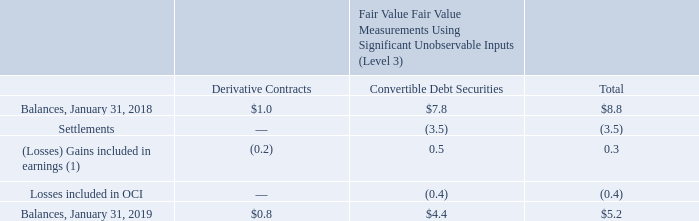Autodesk applies fair value accounting for certain financial assets and liabilities, which consist of cash equivalents, marketable securities, and other financial instruments, on a recurring basis. The Company defines fair value as the price that would be received from selling an asset or paid to transfer a liability in an orderly transaction between market participants at the measurement date. Fair value is estimated by applying the following hierarchy, which prioritizes the inputs used to measure fair value into three levels and bases the categorization within the hierarchy upon the lowest level of input that is available and significant to the fair value measurement: (Level 1) observable inputs such as quoted prices in active markets; (Level 2) inputs other than quoted prices in active markets for identical assets and liabilities, quoted prices for identical or similar assets or liabilities in inactive markets, or other inputs that are observable or can be corroborated by observable market data for substantially the full term of the assets or liabilities; and (Level 3) unobservable inputs for which there is little or no market data, which require Autodesk to develop its own assumptions. When determining fair value, Autodesk uses observable market data and relies on unobservable inputs only when observable market data is not available. Autodesk reviews for any potential changes on a quarterly basis, in conjunction with our fiscal quarter-end close.
Autodesk's cash equivalents, marketable securities, and financial instruments are primarily classified within Level 1 or Level 2 of the fair value hierarchy. Autodesk values its securities on pricing from pricing vendors, who may use quoted prices in active markets for identical assets (Level 1) or inputs other than quoted prices that are observable either directly or indirectly in determining fair value (Level 2). Autodesk's Level 2 securities are valued primarily using observable inputs other than quoted prices in active markets for identical assets and liabilities. Autodesk's Level 3 securities consist of investments held in convertible debt securities, and derivative contracts.
A reconciliation of the change in Autodesk’s Level 3 items for the fiscal year ended January 31, 2019 was as follows:
(1) Included in “Interest and other expense, net” in the accompanying Consolidated Statements of Operations.
What was the balance as of 31 Jan 2019 for convertible debt securities? $4.4. What level(s) are Autodesk's cash equivalents, marketable securities, and financial instruments classified as? Autodesk's cash equivalents, marketable securities, and financial instruments are primarily classified within level 1 or level 2 of the fair value hierarchy. How often does Autodesk review for changes? Autodesk reviews for any potential changes on a quarterly basis, in conjunction with our fiscal quarter-end close. Of the total balances as of January 31, 2019, what percentage came from convertible debt securities?
Answer scale should be: percent. (4.4/5.2)
Answer: 84.62. What is the difference in the balances for derivative contracts for 31 January 2018 and 31 January 2019?
Answer scale should be: million. 1-0.8
Answer: 0.2. How much does the convertible debt securities portion account for the total of change included in earnings?
Answer scale should be: percent. 0.5/0.3 
Answer: 166.67. 